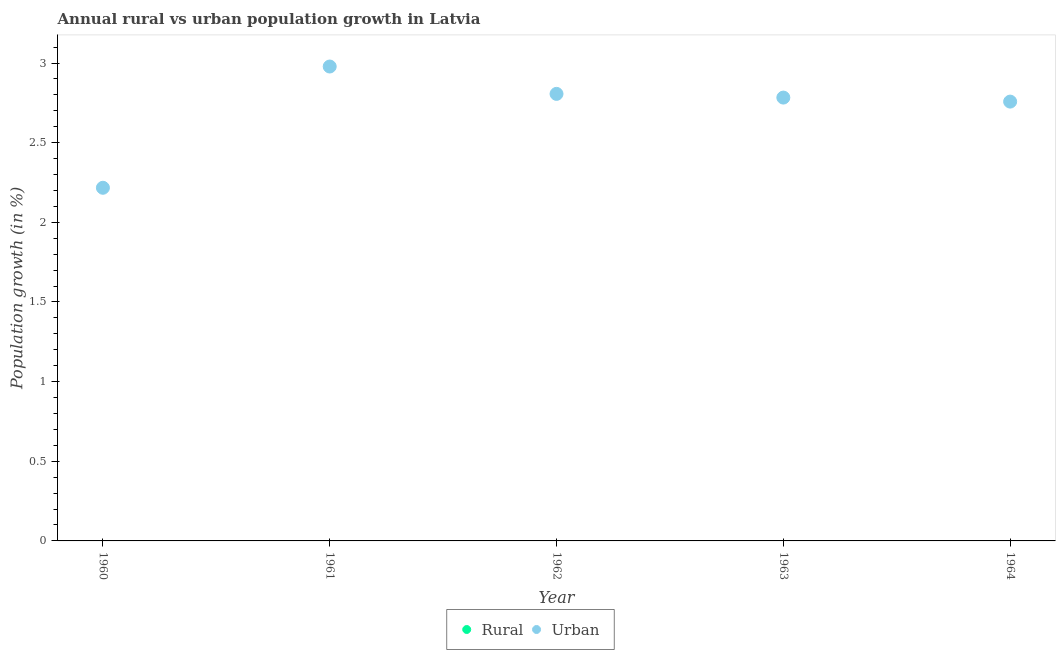How many different coloured dotlines are there?
Your response must be concise. 1. Is the number of dotlines equal to the number of legend labels?
Ensure brevity in your answer.  No. What is the urban population growth in 1961?
Offer a very short reply. 2.98. Across all years, what is the maximum urban population growth?
Your response must be concise. 2.98. Across all years, what is the minimum urban population growth?
Provide a short and direct response. 2.22. What is the total rural population growth in the graph?
Your answer should be very brief. 0. What is the difference between the urban population growth in 1962 and that in 1963?
Your answer should be compact. 0.02. What is the difference between the rural population growth in 1963 and the urban population growth in 1964?
Provide a succinct answer. -2.76. What is the average urban population growth per year?
Provide a short and direct response. 2.71. What is the ratio of the urban population growth in 1960 to that in 1964?
Your answer should be compact. 0.8. Is the urban population growth in 1960 less than that in 1961?
Offer a very short reply. Yes. What is the difference between the highest and the second highest urban population growth?
Keep it short and to the point. 0.17. What is the difference between the highest and the lowest urban population growth?
Keep it short and to the point. 0.76. Does the urban population growth monotonically increase over the years?
Keep it short and to the point. No. What is the difference between two consecutive major ticks on the Y-axis?
Your answer should be compact. 0.5. Are the values on the major ticks of Y-axis written in scientific E-notation?
Your response must be concise. No. Does the graph contain any zero values?
Keep it short and to the point. Yes. Does the graph contain grids?
Provide a short and direct response. No. Where does the legend appear in the graph?
Your response must be concise. Bottom center. How many legend labels are there?
Offer a very short reply. 2. How are the legend labels stacked?
Ensure brevity in your answer.  Horizontal. What is the title of the graph?
Your answer should be compact. Annual rural vs urban population growth in Latvia. Does "Primary completion rate" appear as one of the legend labels in the graph?
Ensure brevity in your answer.  No. What is the label or title of the Y-axis?
Ensure brevity in your answer.  Population growth (in %). What is the Population growth (in %) in Rural in 1960?
Your answer should be compact. 0. What is the Population growth (in %) of Urban  in 1960?
Provide a succinct answer. 2.22. What is the Population growth (in %) in Rural in 1961?
Offer a terse response. 0. What is the Population growth (in %) in Urban  in 1961?
Ensure brevity in your answer.  2.98. What is the Population growth (in %) of Rural in 1962?
Make the answer very short. 0. What is the Population growth (in %) in Urban  in 1962?
Your response must be concise. 2.81. What is the Population growth (in %) in Urban  in 1963?
Offer a very short reply. 2.78. What is the Population growth (in %) of Rural in 1964?
Your response must be concise. 0. What is the Population growth (in %) in Urban  in 1964?
Keep it short and to the point. 2.76. Across all years, what is the maximum Population growth (in %) of Urban ?
Offer a very short reply. 2.98. Across all years, what is the minimum Population growth (in %) of Urban ?
Your answer should be compact. 2.22. What is the total Population growth (in %) of Rural in the graph?
Give a very brief answer. 0. What is the total Population growth (in %) of Urban  in the graph?
Provide a succinct answer. 13.54. What is the difference between the Population growth (in %) in Urban  in 1960 and that in 1961?
Ensure brevity in your answer.  -0.76. What is the difference between the Population growth (in %) of Urban  in 1960 and that in 1962?
Give a very brief answer. -0.59. What is the difference between the Population growth (in %) in Urban  in 1960 and that in 1963?
Offer a very short reply. -0.57. What is the difference between the Population growth (in %) of Urban  in 1960 and that in 1964?
Your response must be concise. -0.54. What is the difference between the Population growth (in %) in Urban  in 1961 and that in 1962?
Offer a very short reply. 0.17. What is the difference between the Population growth (in %) in Urban  in 1961 and that in 1963?
Make the answer very short. 0.2. What is the difference between the Population growth (in %) of Urban  in 1961 and that in 1964?
Offer a terse response. 0.22. What is the difference between the Population growth (in %) in Urban  in 1962 and that in 1963?
Give a very brief answer. 0.02. What is the difference between the Population growth (in %) of Urban  in 1962 and that in 1964?
Offer a terse response. 0.05. What is the difference between the Population growth (in %) of Urban  in 1963 and that in 1964?
Provide a short and direct response. 0.03. What is the average Population growth (in %) of Urban  per year?
Provide a short and direct response. 2.71. What is the ratio of the Population growth (in %) in Urban  in 1960 to that in 1961?
Make the answer very short. 0.74. What is the ratio of the Population growth (in %) of Urban  in 1960 to that in 1962?
Ensure brevity in your answer.  0.79. What is the ratio of the Population growth (in %) in Urban  in 1960 to that in 1963?
Provide a succinct answer. 0.8. What is the ratio of the Population growth (in %) in Urban  in 1960 to that in 1964?
Your response must be concise. 0.8. What is the ratio of the Population growth (in %) of Urban  in 1961 to that in 1962?
Offer a terse response. 1.06. What is the ratio of the Population growth (in %) in Urban  in 1961 to that in 1963?
Provide a succinct answer. 1.07. What is the ratio of the Population growth (in %) of Urban  in 1961 to that in 1964?
Keep it short and to the point. 1.08. What is the ratio of the Population growth (in %) of Urban  in 1962 to that in 1963?
Ensure brevity in your answer.  1.01. What is the ratio of the Population growth (in %) in Urban  in 1962 to that in 1964?
Your response must be concise. 1.02. What is the ratio of the Population growth (in %) of Urban  in 1963 to that in 1964?
Offer a terse response. 1.01. What is the difference between the highest and the second highest Population growth (in %) of Urban ?
Provide a succinct answer. 0.17. What is the difference between the highest and the lowest Population growth (in %) in Urban ?
Offer a terse response. 0.76. 